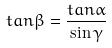<formula> <loc_0><loc_0><loc_500><loc_500>t a n \beta = \frac { t a n \alpha } { \sin \gamma }</formula> 